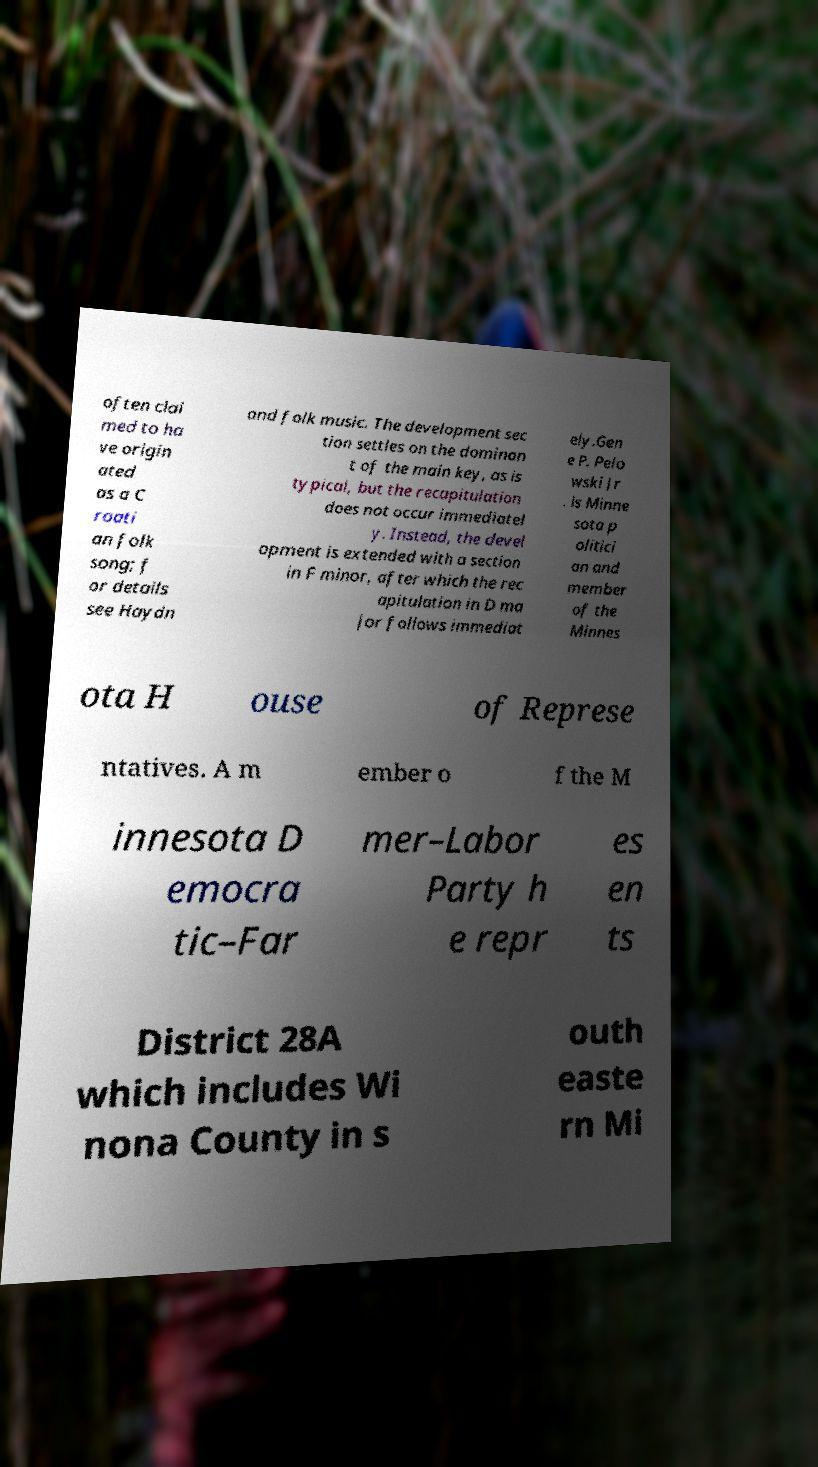Could you assist in decoding the text presented in this image and type it out clearly? often clai med to ha ve origin ated as a C roati an folk song; f or details see Haydn and folk music. The development sec tion settles on the dominan t of the main key, as is typical, but the recapitulation does not occur immediatel y. Instead, the devel opment is extended with a section in F minor, after which the rec apitulation in D ma jor follows immediat ely.Gen e P. Pelo wski Jr . is Minne sota p olitici an and member of the Minnes ota H ouse of Represe ntatives. A m ember o f the M innesota D emocra tic–Far mer–Labor Party h e repr es en ts District 28A which includes Wi nona County in s outh easte rn Mi 